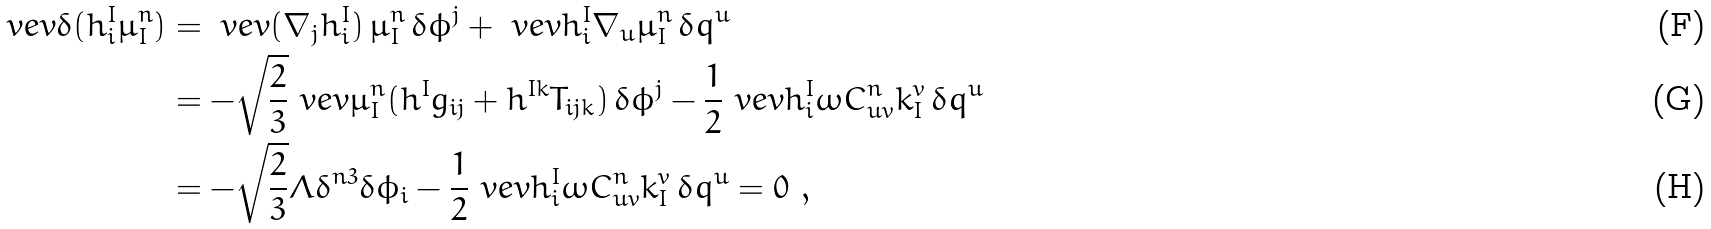Convert formula to latex. <formula><loc_0><loc_0><loc_500><loc_500>\ v e v { \delta ( h _ { i } ^ { I } \mu ^ { n } _ { I } ) } & = \ v e v { ( \nabla _ { j } h _ { i } ^ { I } ) \, \mu ^ { n } _ { I } } \, \delta \phi ^ { j } + \ v e v { h _ { i } ^ { I } \nabla _ { u } \mu _ { I } ^ { n } } \, \delta q ^ { u } \\ & = - \sqrt { \frac { 2 } { 3 } } \ v e v { \mu ^ { n } _ { I } ( h ^ { I } g _ { i j } + h ^ { I k } T _ { i j k } ) } \, \delta \phi ^ { j } - \frac { 1 } { 2 } \ v e v { h ^ { I } _ { i } \omega C ^ { n } _ { u v } k ^ { v } _ { I } } \, \delta q ^ { u } \\ & = - \sqrt { \frac { 2 } { 3 } } \Lambda \delta ^ { n 3 } \delta \phi _ { i } - \frac { 1 } { 2 } \ v e v { h ^ { I } _ { i } \omega C ^ { n } _ { u v } k ^ { v } _ { I } } \, \delta q ^ { u } = 0 \ ,</formula> 